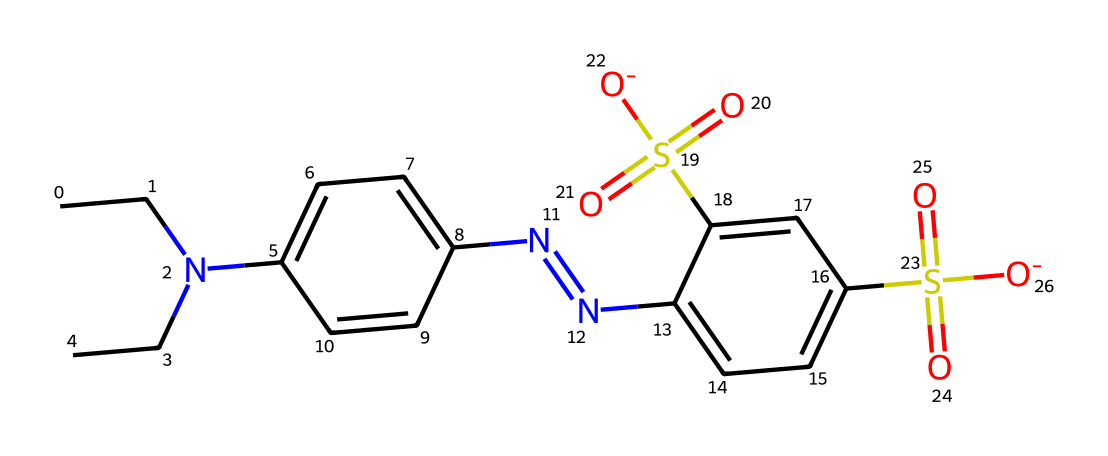What is the molecular formula of this dye? To determine the molecular formula, count the number of each type of atom present in the SMILES representation. The structure contains carbon (C), hydrogen (H), nitrogen (N), sulfur (S), and oxygen (O). The counts are: C=15, H=18, N=4, S=2, O=4. Therefore, the molecular formula is C15H18N4S2O4.
Answer: C15H18N4S2O4 How many double bonds are present in the structure? In the SMILES representation, double bonds can be identified by the presence of '=' symbols. Analyzing the structure, there are two double bonds in the molecule. Therefore, the answer is two.
Answer: 2 What type of functional group is present at the end of the molecule? The presence of the sulfonate (-S(=O)(=O)[O-]) groups suggests that this molecule has sulfonic acid functional groups. These groups are characterized by the sulfur atom bonded to oxygen atoms with double bonds and negatively charged oxygen.
Answer: sulfonic acid Is this dye likely to be water-soluble? Dyes containing sulfonic acid groups are generally more soluble in water due to the polar nature of the sulfonate groups, which can interact with water molecules through hydrogen bonding and ionic interactions. Given the presence of sulfonic acid groups in this structure, it would likely be water-soluble.
Answer: yes What is the role of the nitrogen atoms in this dye? The nitrogen atoms in this dye, particularly those connected with the azo (-N=N-) functional group, are essential for the dye's ability to absorb visible light, imparting color. The azo bond contributes to the chromophore system, influencing color properties.
Answer: color absorption 